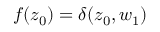<formula> <loc_0><loc_0><loc_500><loc_500>{ f ( z _ { 0 } ) = \delta ( z _ { 0 } , w _ { 1 } ) }</formula> 